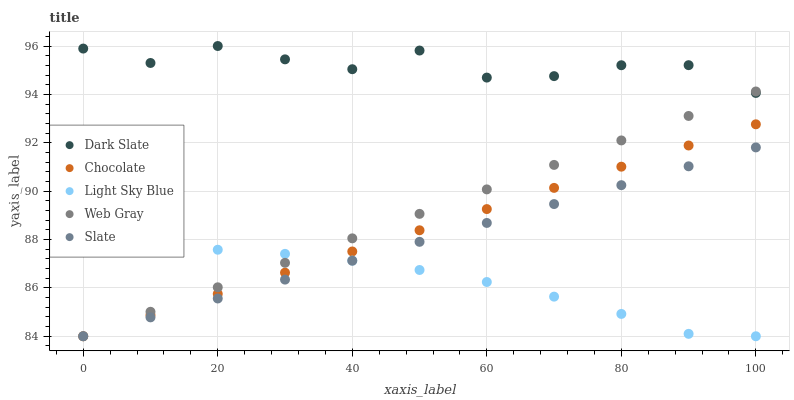Does Light Sky Blue have the minimum area under the curve?
Answer yes or no. Yes. Does Dark Slate have the maximum area under the curve?
Answer yes or no. Yes. Does Slate have the minimum area under the curve?
Answer yes or no. No. Does Slate have the maximum area under the curve?
Answer yes or no. No. Is Web Gray the smoothest?
Answer yes or no. Yes. Is Dark Slate the roughest?
Answer yes or no. Yes. Is Slate the smoothest?
Answer yes or no. No. Is Slate the roughest?
Answer yes or no. No. Does Slate have the lowest value?
Answer yes or no. Yes. Does Dark Slate have the highest value?
Answer yes or no. Yes. Does Slate have the highest value?
Answer yes or no. No. Is Slate less than Dark Slate?
Answer yes or no. Yes. Is Dark Slate greater than Chocolate?
Answer yes or no. Yes. Does Chocolate intersect Light Sky Blue?
Answer yes or no. Yes. Is Chocolate less than Light Sky Blue?
Answer yes or no. No. Is Chocolate greater than Light Sky Blue?
Answer yes or no. No. Does Slate intersect Dark Slate?
Answer yes or no. No. 